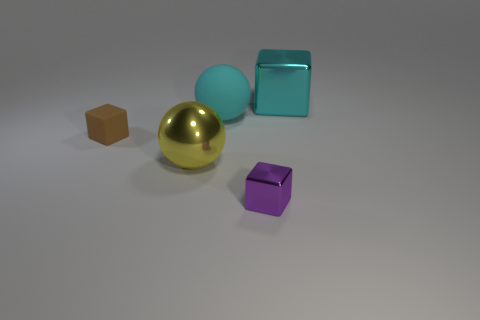Add 2 cyan cubes. How many objects exist? 7 Subtract all cubes. How many objects are left? 2 Add 1 big yellow shiny things. How many big yellow shiny things exist? 2 Subtract 0 green cylinders. How many objects are left? 5 Subtract all tiny balls. Subtract all large metallic things. How many objects are left? 3 Add 3 small brown objects. How many small brown objects are left? 4 